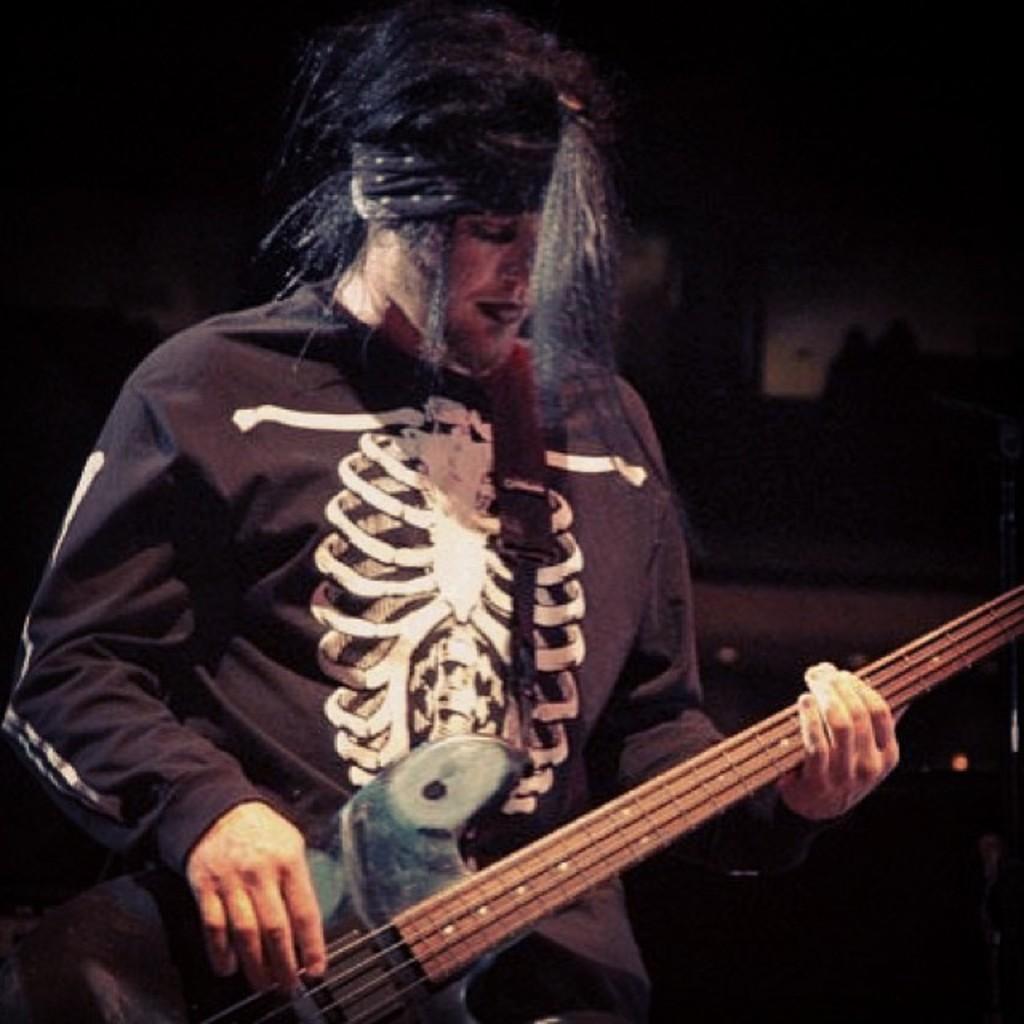In one or two sentences, can you explain what this image depicts? In this image, In the middle there is a man standing and he is holding a music instrument which is in yellow color. 